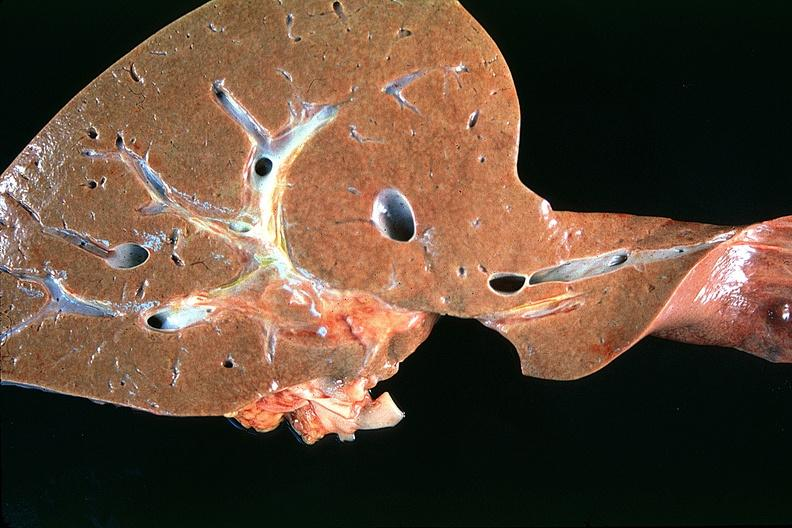does this image show normal liver?
Answer the question using a single word or phrase. Yes 